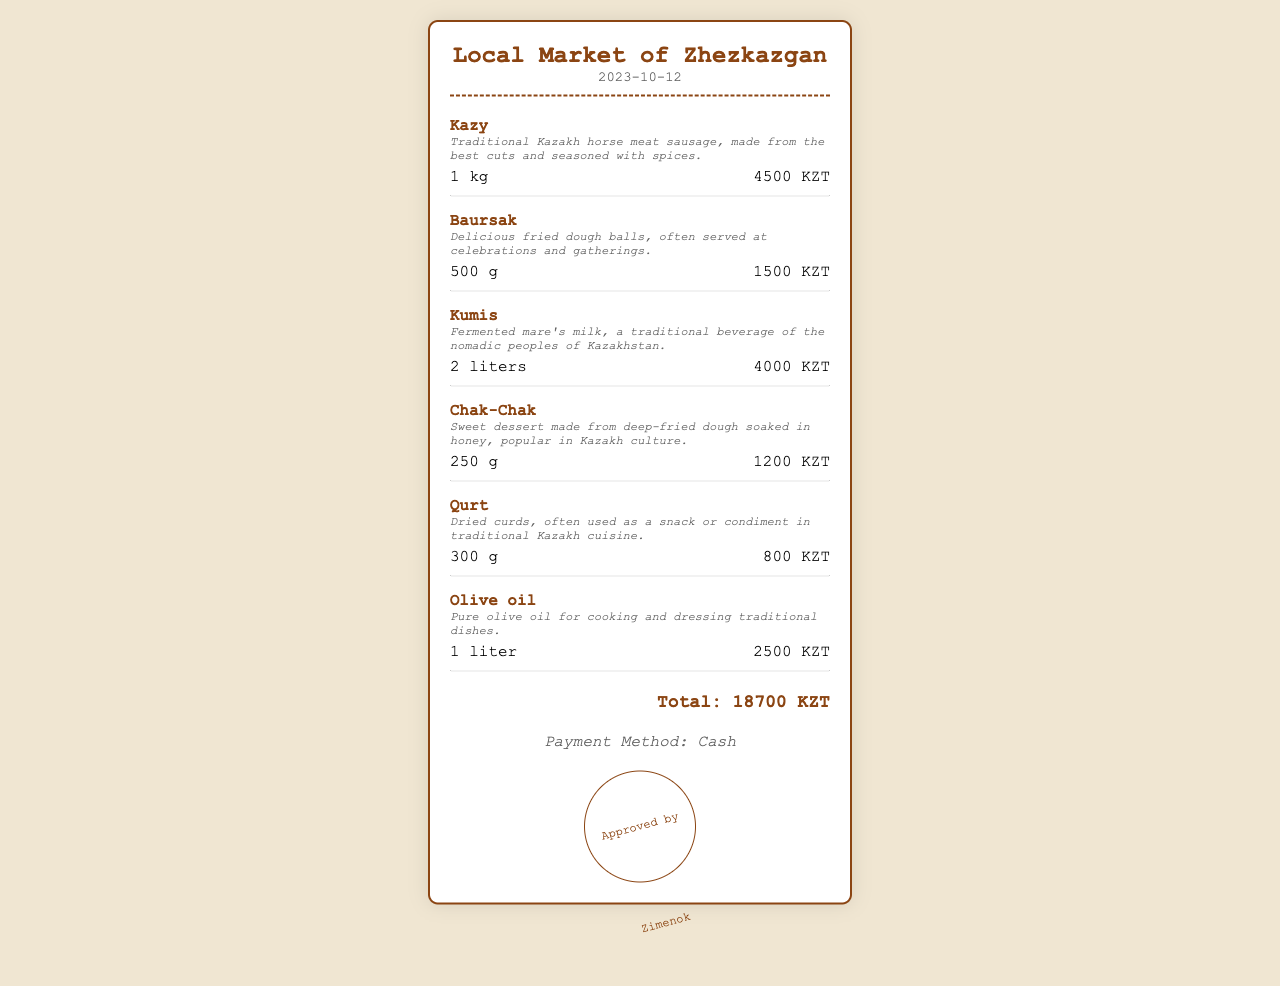What is the name of the store? The store name is mentioned at the top of the receipt as the Local Market of Zhezkazgan.
Answer: Local Market of Zhezkazgan What is the date of the receipt? The date of the transaction is shown under the store name in the header section of the receipt.
Answer: 2023-10-12 How much is Kazy per kilogram? The unit price of Kazy is clearly listed next to the item, which states the cost for 1 kg.
Answer: 4500 KZT What quantity of Kumis was purchased? The quantity of Kumis purchased is stated in liters next to the item description in the receipt.
Answer: 2 liters What is the total amount spent? The total amount at the bottom of the receipt summarizes all purchases made.
Answer: 18700 KZT What is the payment method used? The payment method is specified towards the end of the receipt, indicating how the payment was made.
Answer: Cash Who approved the receipt? The name mentioned in the stamped area at the bottom indicates who approved the receipt.
Answer: Zimenok What is the weight of Baursak purchased? The weight of Baursak is detailed near the item, specifying its quantity in grams.
Answer: 500 g What type of product is Qurt classified as? The description for Qurt indicates it is a type of snack or condiment in Kazakh cuisine.
Answer: Snack 